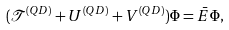<formula> <loc_0><loc_0><loc_500><loc_500>( { \mathcal { T } } ^ { ( Q D ) } + U ^ { ( Q D ) } + V ^ { ( Q D ) } ) \Phi = \bar { E } \Phi ,</formula> 